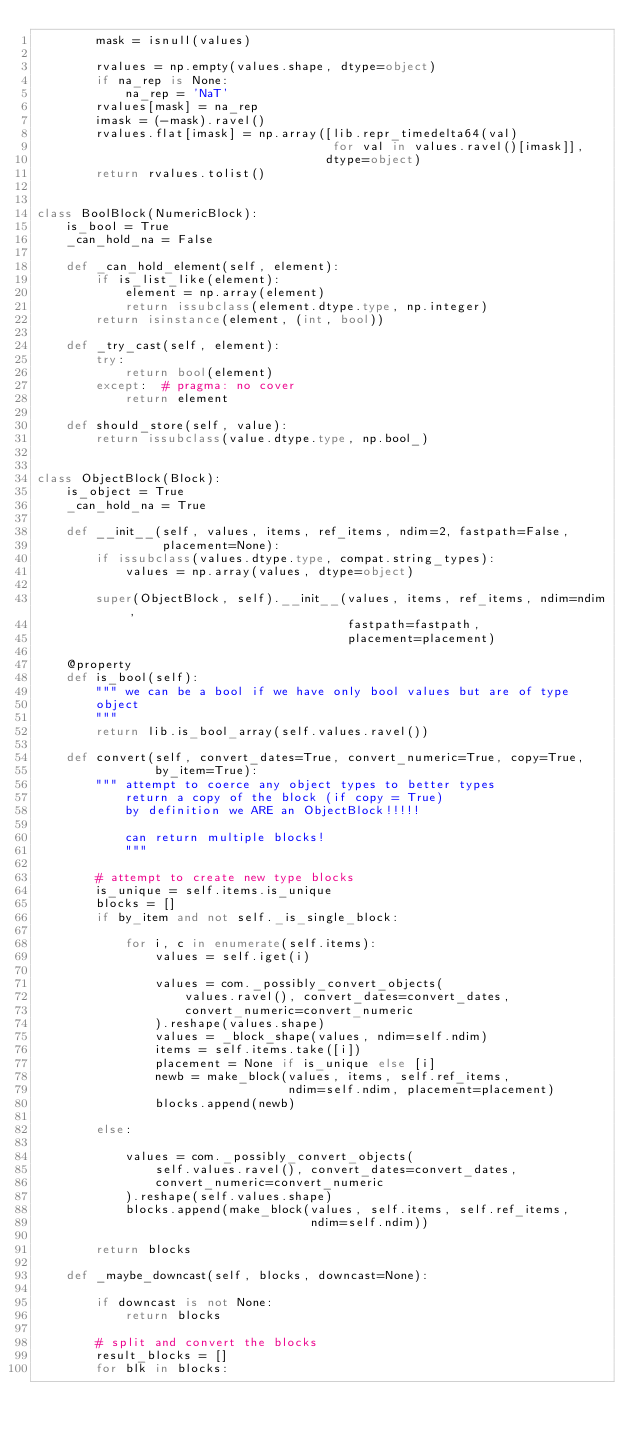Convert code to text. <code><loc_0><loc_0><loc_500><loc_500><_Python_>        mask = isnull(values)

        rvalues = np.empty(values.shape, dtype=object)
        if na_rep is None:
            na_rep = 'NaT'
        rvalues[mask] = na_rep
        imask = (-mask).ravel()
        rvalues.flat[imask] = np.array([lib.repr_timedelta64(val)
                                        for val in values.ravel()[imask]],
                                       dtype=object)
        return rvalues.tolist()


class BoolBlock(NumericBlock):
    is_bool = True
    _can_hold_na = False

    def _can_hold_element(self, element):
        if is_list_like(element):
            element = np.array(element)
            return issubclass(element.dtype.type, np.integer)
        return isinstance(element, (int, bool))

    def _try_cast(self, element):
        try:
            return bool(element)
        except:  # pragma: no cover
            return element

    def should_store(self, value):
        return issubclass(value.dtype.type, np.bool_)


class ObjectBlock(Block):
    is_object = True
    _can_hold_na = True

    def __init__(self, values, items, ref_items, ndim=2, fastpath=False,
                 placement=None):
        if issubclass(values.dtype.type, compat.string_types):
            values = np.array(values, dtype=object)

        super(ObjectBlock, self).__init__(values, items, ref_items, ndim=ndim,
                                          fastpath=fastpath,
                                          placement=placement)

    @property
    def is_bool(self):
        """ we can be a bool if we have only bool values but are of type
        object
        """
        return lib.is_bool_array(self.values.ravel())

    def convert(self, convert_dates=True, convert_numeric=True, copy=True,
                by_item=True):
        """ attempt to coerce any object types to better types
            return a copy of the block (if copy = True)
            by definition we ARE an ObjectBlock!!!!!

            can return multiple blocks!
            """

        # attempt to create new type blocks
        is_unique = self.items.is_unique
        blocks = []
        if by_item and not self._is_single_block:

            for i, c in enumerate(self.items):
                values = self.iget(i)

                values = com._possibly_convert_objects(
                    values.ravel(), convert_dates=convert_dates,
                    convert_numeric=convert_numeric
                ).reshape(values.shape)
                values = _block_shape(values, ndim=self.ndim)
                items = self.items.take([i])
                placement = None if is_unique else [i]
                newb = make_block(values, items, self.ref_items,
                                  ndim=self.ndim, placement=placement)
                blocks.append(newb)

        else:

            values = com._possibly_convert_objects(
                self.values.ravel(), convert_dates=convert_dates,
                convert_numeric=convert_numeric
            ).reshape(self.values.shape)
            blocks.append(make_block(values, self.items, self.ref_items,
                                     ndim=self.ndim))

        return blocks

    def _maybe_downcast(self, blocks, downcast=None):

        if downcast is not None:
            return blocks

        # split and convert the blocks
        result_blocks = []
        for blk in blocks:</code> 